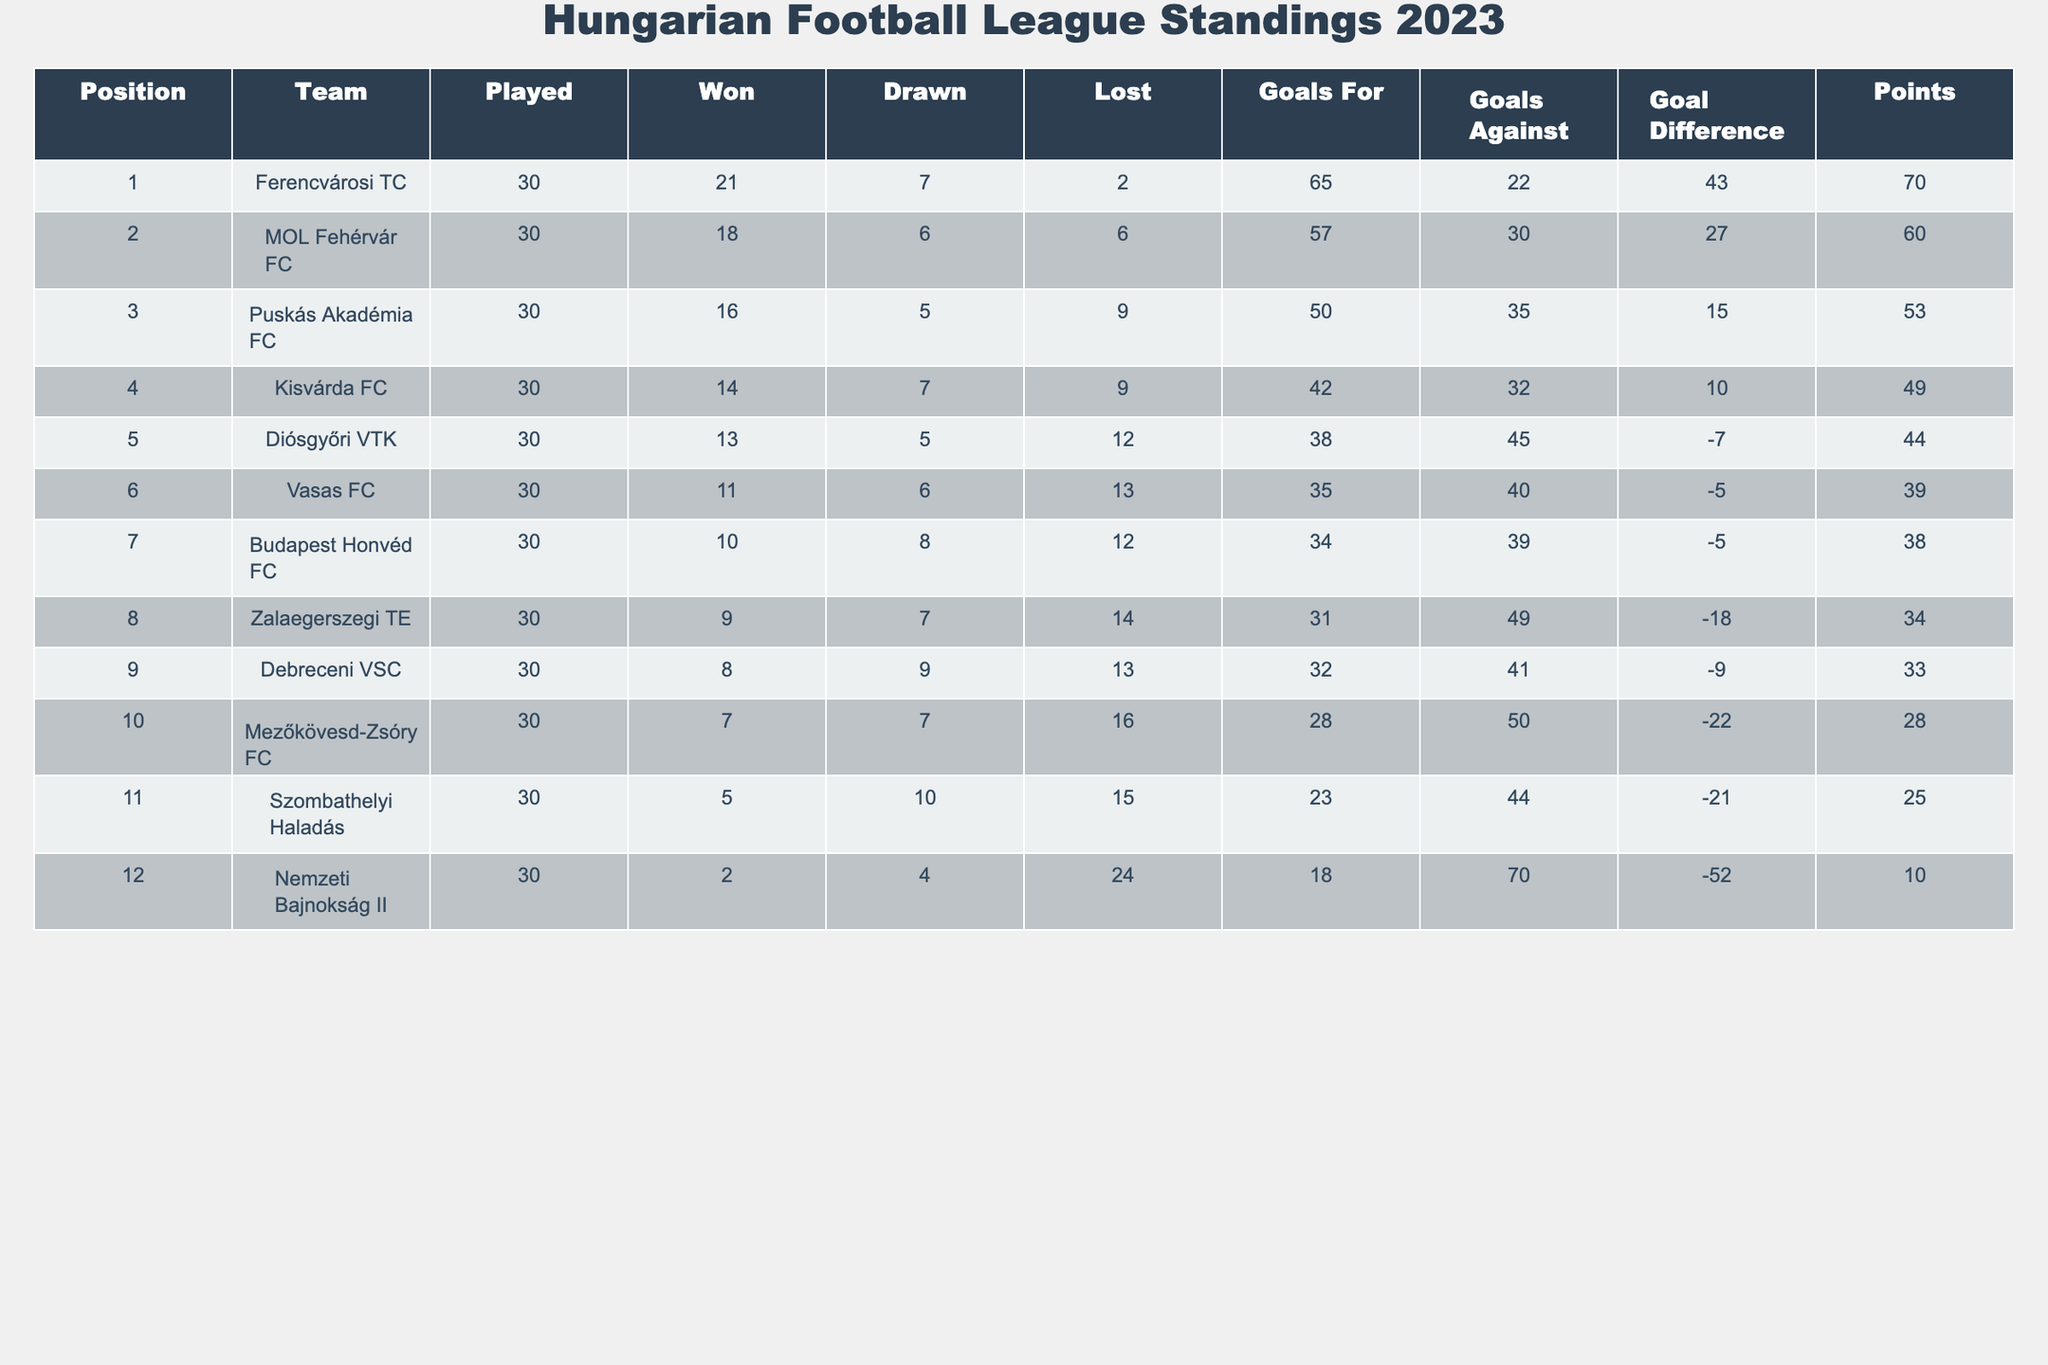What team has the most points in the table? The table shows that Ferencvárosi TC is in the first position with 70 points, which is the highest number in the Points column.
Answer: Ferencvárosi TC How many goals did MOL Fehérvár FC score? The Goals For column indicates that MOL Fehérvár FC scored 57 goals, which is depicted alongside their statistics.
Answer: 57 What is the goal difference for Puskás Akadémia FC? Puskás Akadémia FC has a Goal Difference of 15, which can be found in the respective column of the table.
Answer: 15 Which team has the worst goal difference? The team with the worst Goal Difference is Nemzeti Bajnokság II, with a goal difference of -52, as shown in the Goal Difference column.
Answer: Nemzeti Bajnokság II How many matches did Kisvárda FC play this season? The Played column indicates that Kisvárda FC played 30 matches in total.
Answer: 30 What is the average number of goals scored (Goals For) by the teams in the table? To find the average, we sum the Goals For column (65 + 57 + 50 + 42 + 38 + 35 + 34 + 31 + 32 + 28 + 23 + 18 =  403) and divide by the total number of teams (12): 403 / 12 = 33.58.
Answer: 33.58 Did any team finish the season with fewer than 30 points? Yes, the table shows that both Mezőkövesd-Zsóry FC (28 points) and Nemzeti Bajnokság II (10 points) finished with fewer than 30 points.
Answer: Yes How many points did the team in fourth place earn? The table indicates that Kisvárda FC, the team in fourth place, earned 49 points, which is listed under the Points column.
Answer: 49 Which team lost the most matches? By examining the Lost column, we see that Nemzeti Bajnokság II lost 24 matches, which is the highest among all teams.
Answer: Nemzeti Bajnokság II If you take the first three teams and sum their points, what would that total be? We take the points of the top three teams: Ferencvárosi TC (70) + MOL Fehérvár FC (60) + Puskás Akadémia FC (53) = 70 + 60 + 53 = 183.
Answer: 183 